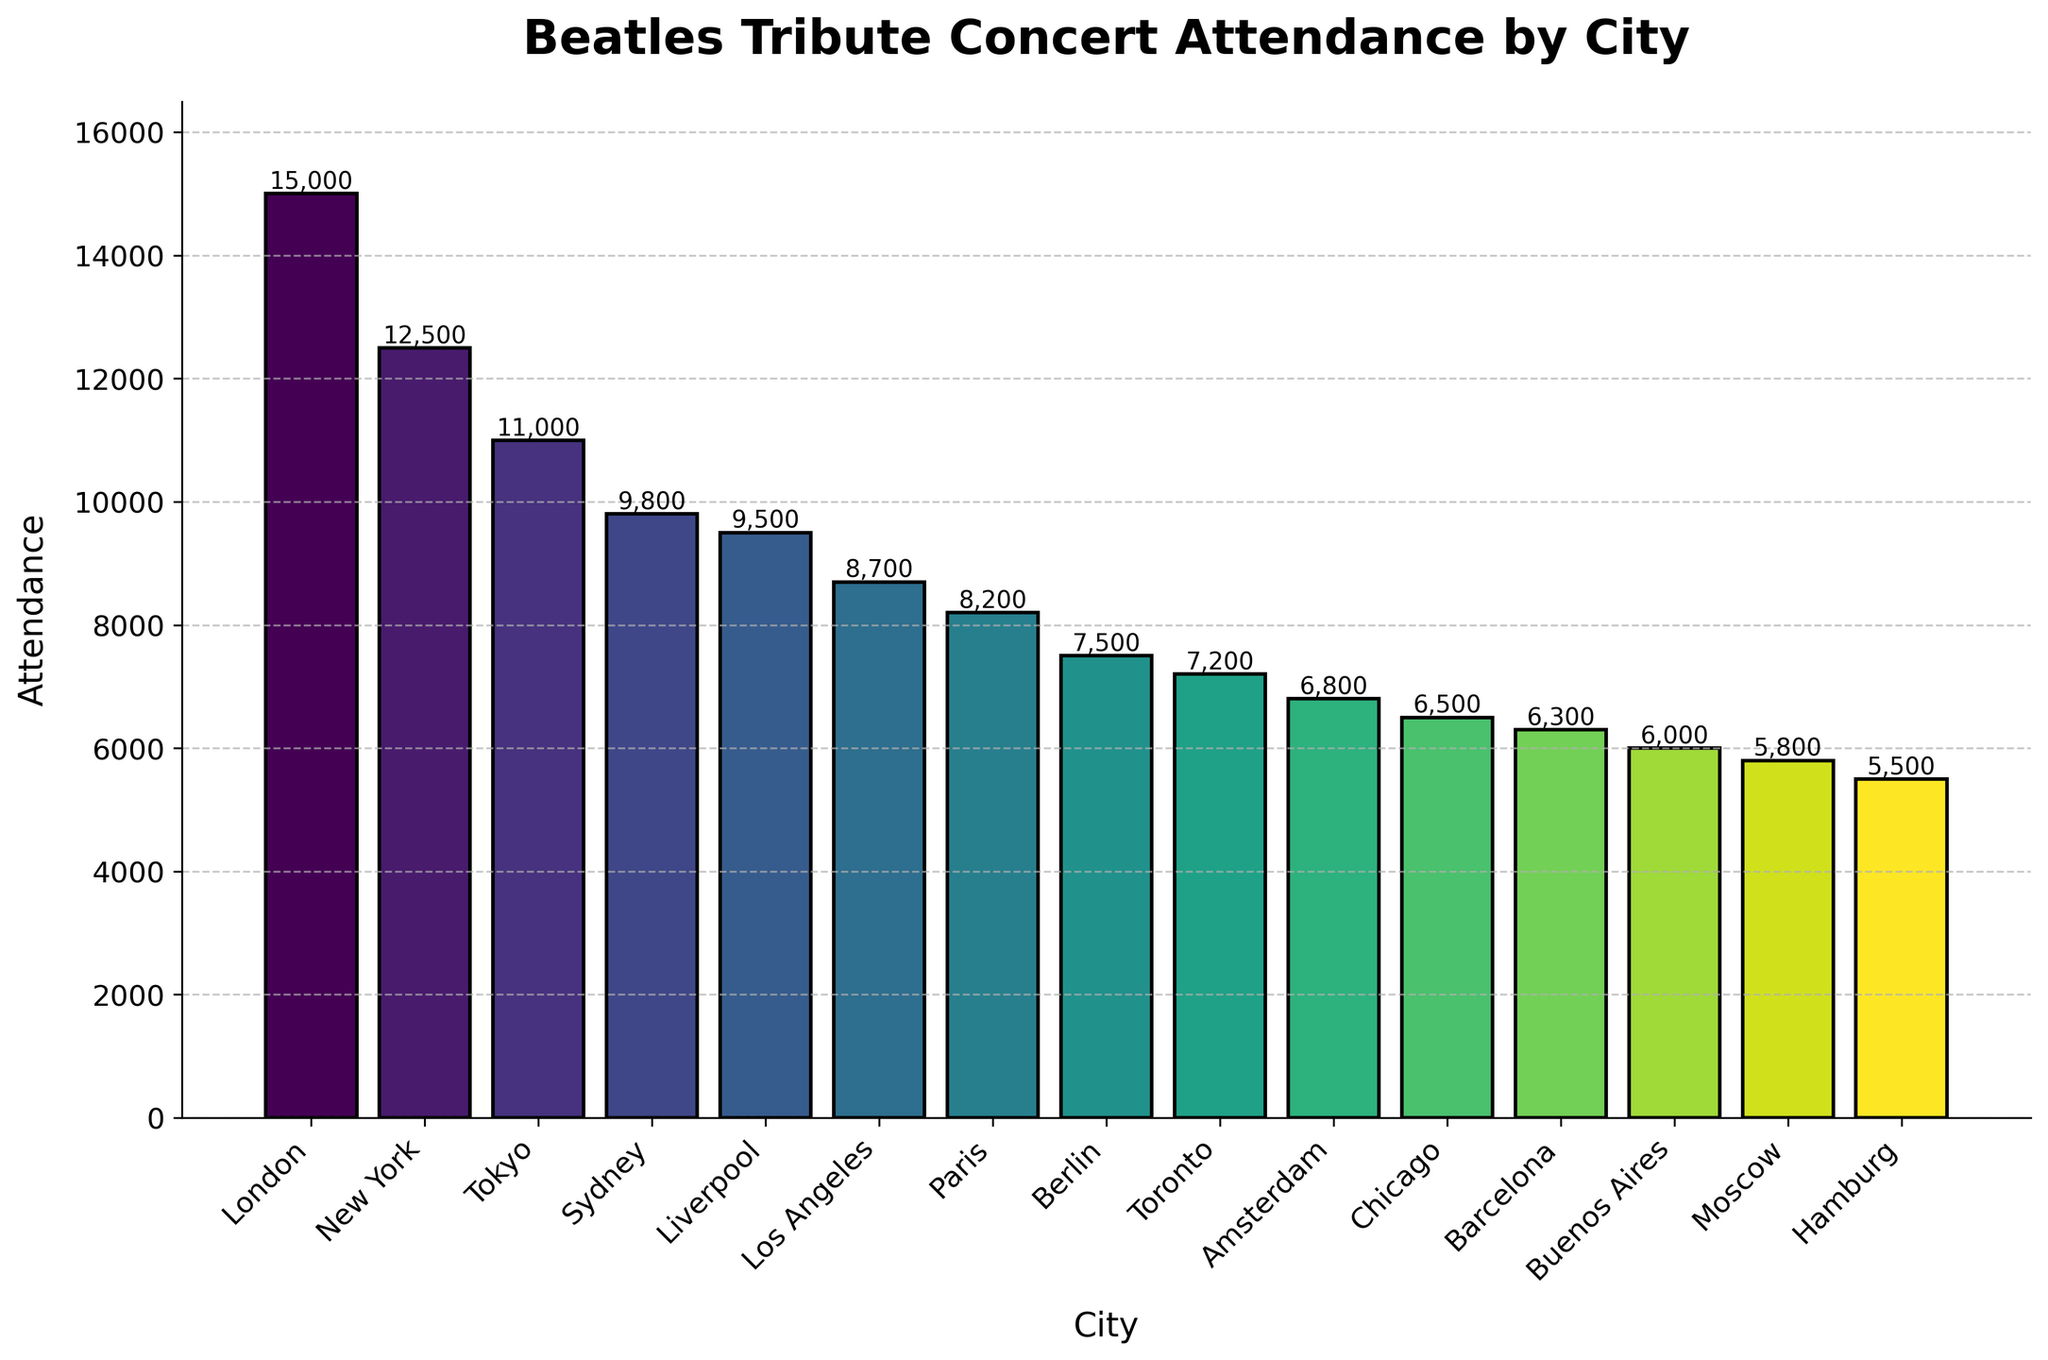What's the city with the highest attendance? The bar chart shows the attendance figures for each city. The tallest bar represents the highest attendance, which is for London at 15,000.
Answer: London Which city has a higher attendance, Tokyo or Sydney? By comparing the heights of the bars, Tokyo has an attendance of 11,000 while Sydney's is 9,800. Since 11,000 is greater than 9,800, Tokyo has higher attendance.
Answer: Tokyo What's the difference in attendance between New York and Los Angeles? The bar for New York shows 12,500 attendees, while Los Angeles has 8,700. The difference is 12,500 - 8,700 = 3,800.
Answer: 3,800 What is the total attendance for the top three cities? The top three cities by attendance are London (15,000), New York (12,500), and Tokyo (11,000). Adding these together gives 15,000 + 12,500 + 11,000 = 38,500.
Answer: 38,500 Which city has the lowest attendance, and what is the figure? The shortest bar in the chart represents Hamburg, with an attendance of 5,500.
Answer: Hamburg, 5,500 How many cities have attendance figures above 8,000? Counting the bars that reach above the 8,000 mark, we have London, New York, Tokyo, Sydney, Liverpool, Los Angeles, and Paris. This totals to 7 cities.
Answer: 7 Is the attendance in Paris more than double that in Hamburg? Paris has an attendance of 8,200. Hamburg has 5,500. Doubling Hamburg’s attendance gives 5,500 * 2 = 11,000. Since 8,200 is less than 11,000, Paris's attendance is not more than double that of Hamburg.
Answer: No What's the average attendance for the cities with attendance figures below 7,000? The cities with attendance figures below 7,000 are Toronto (7,200), Amsterdam (6,800), Chicago (6,500), Barcelona (6,300), Buenos Aires (6,000), Moscow (5,800), and Hamburg (5,500). Their attendance summed equals 7,200 + 6,800 + 6,500 + 6,300 + 6,000 + 5,800 + 5,500 = 44,100. Dividing by the number of cities (7) gives 44,100 / 7 ≈ 6,300.
Answer: 6,300 Which cities see a decline in attendance figures, specifically comparing Berlin and Moscow? Berlin has an attendance of 7,500 while Moscow has 5,800. Since 7,500 is greater than 5,800, Berlin has higher attendance compared to Moscow, indicating a decline when moving from Berlin to Moscow.
Answer: Moscow 